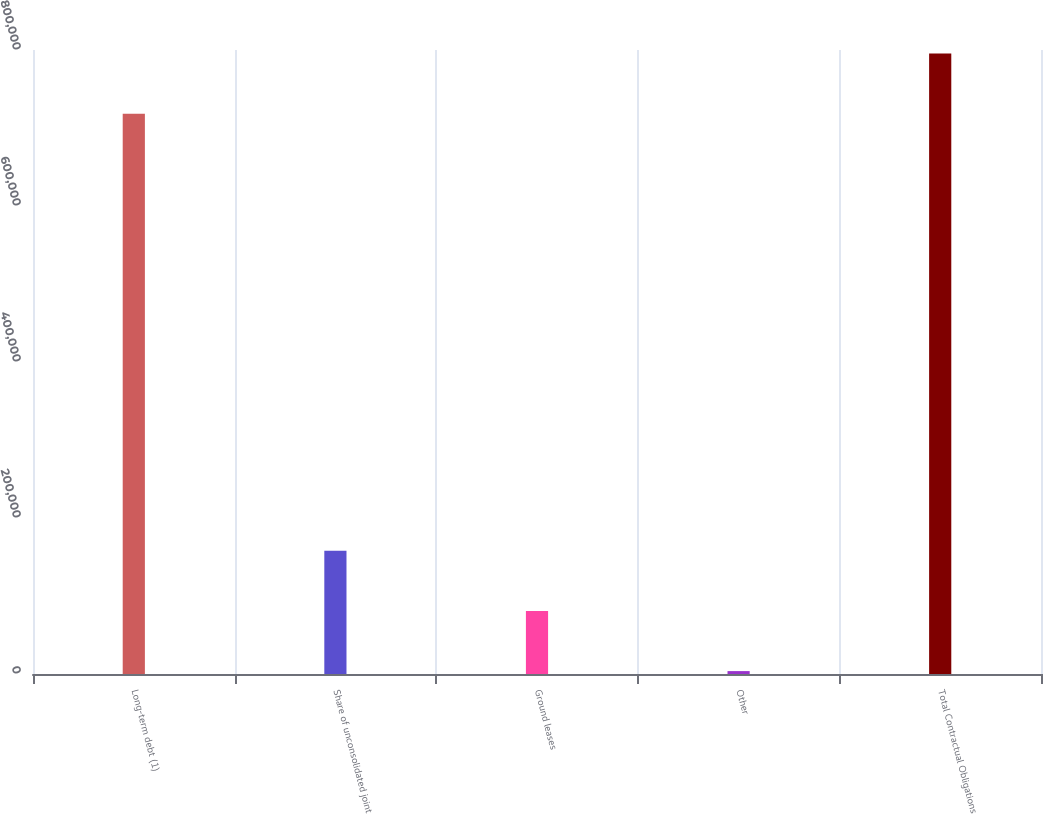<chart> <loc_0><loc_0><loc_500><loc_500><bar_chart><fcel>Long-term debt (1)<fcel>Share of unconsolidated joint<fcel>Ground leases<fcel>Other<fcel>Total Contractual Obligations<nl><fcel>718319<fcel>158134<fcel>80922.5<fcel>3711<fcel>795530<nl></chart> 